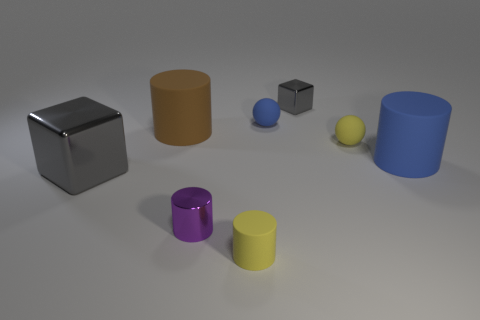Subtract 1 cylinders. How many cylinders are left? 3 Add 1 big brown things. How many objects exist? 9 Subtract all spheres. How many objects are left? 6 Add 7 yellow matte objects. How many yellow matte objects exist? 9 Subtract 1 yellow cylinders. How many objects are left? 7 Subtract all brown rubber cylinders. Subtract all small matte spheres. How many objects are left? 5 Add 8 large blue cylinders. How many large blue cylinders are left? 9 